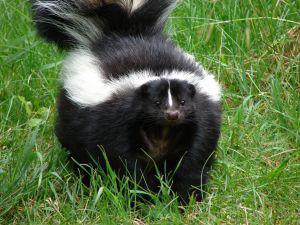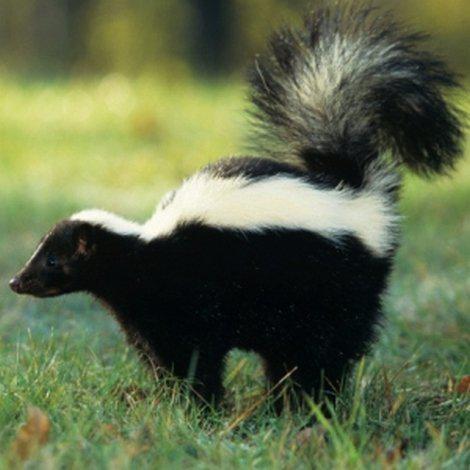The first image is the image on the left, the second image is the image on the right. Considering the images on both sides, is "There are a total of exactly two skunks in the grass." valid? Answer yes or no. Yes. The first image is the image on the left, the second image is the image on the right. For the images shown, is this caption "One image contains twice as many skunks as the other image." true? Answer yes or no. No. 